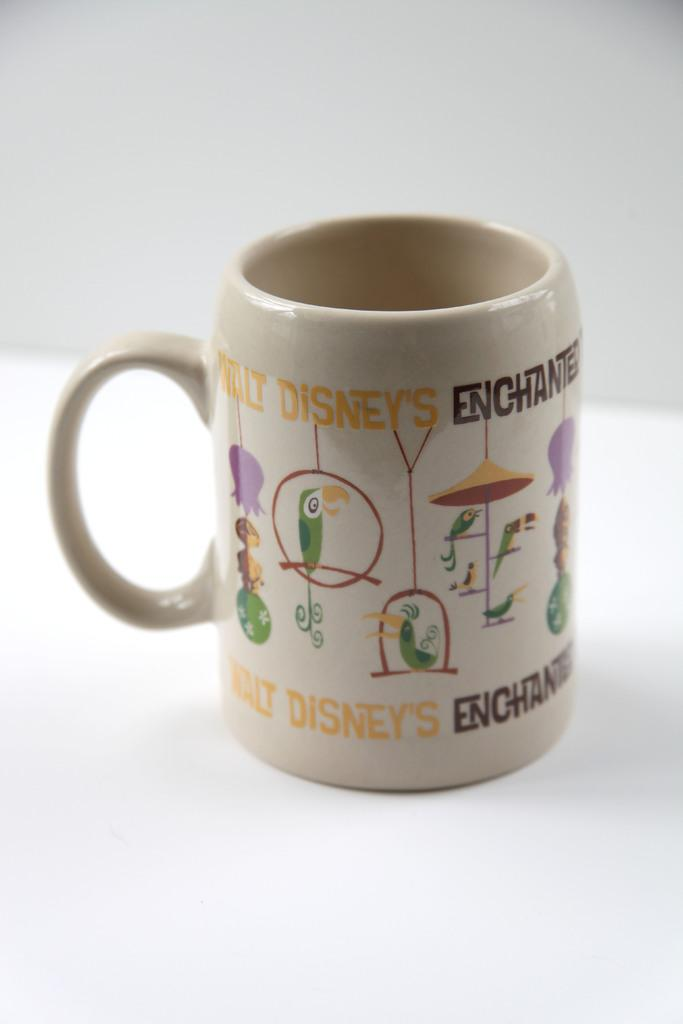<image>
Render a clear and concise summary of the photo. A mug that says Walt Disney's Enchanted and has birds on it. 